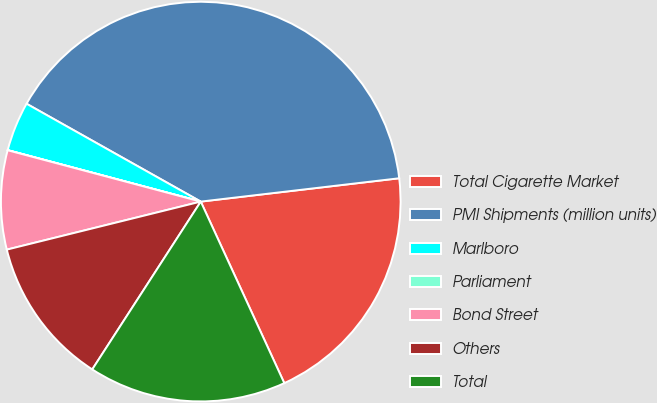<chart> <loc_0><loc_0><loc_500><loc_500><pie_chart><fcel>Total Cigarette Market<fcel>PMI Shipments (million units)<fcel>Marlboro<fcel>Parliament<fcel>Bond Street<fcel>Others<fcel>Total<nl><fcel>20.0%<fcel>39.99%<fcel>4.0%<fcel>0.01%<fcel>8.0%<fcel>12.0%<fcel>16.0%<nl></chart> 